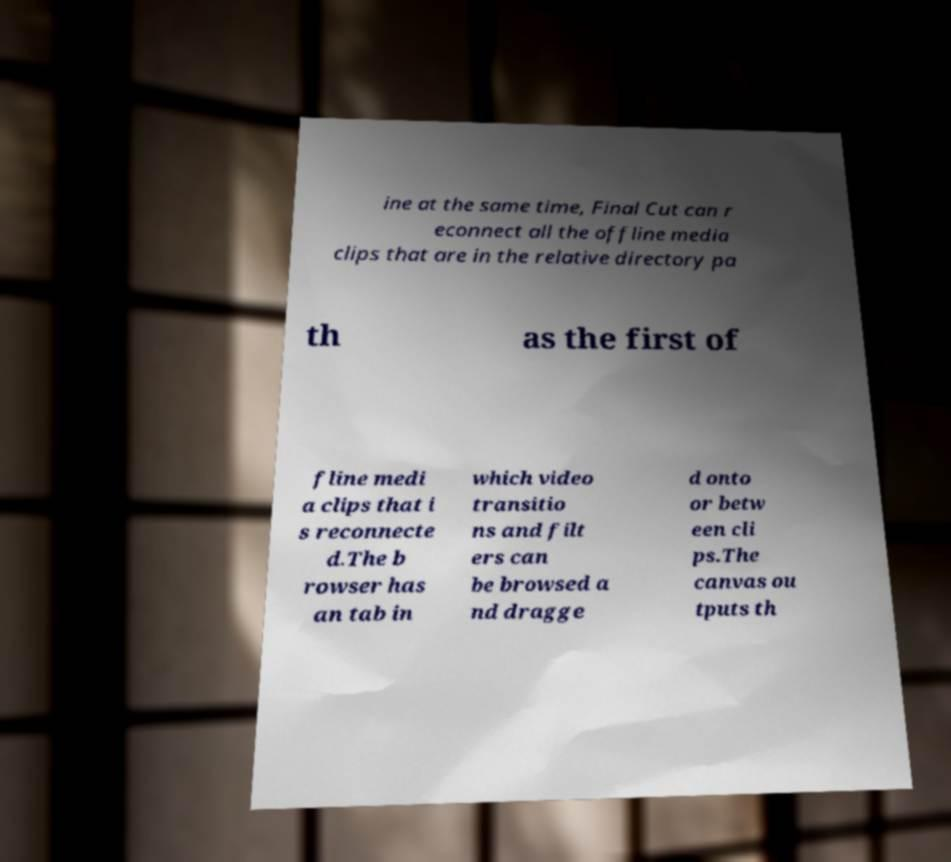Please read and relay the text visible in this image. What does it say? ine at the same time, Final Cut can r econnect all the offline media clips that are in the relative directory pa th as the first of fline medi a clips that i s reconnecte d.The b rowser has an tab in which video transitio ns and filt ers can be browsed a nd dragge d onto or betw een cli ps.The canvas ou tputs th 